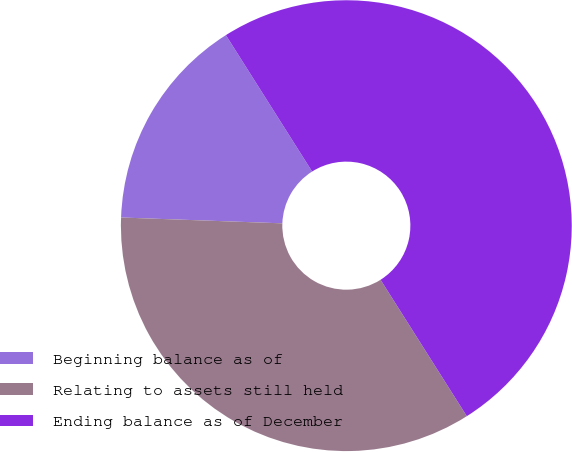Convert chart to OTSL. <chart><loc_0><loc_0><loc_500><loc_500><pie_chart><fcel>Beginning balance as of<fcel>Relating to assets still held<fcel>Ending balance as of December<nl><fcel>15.45%<fcel>34.55%<fcel>50.0%<nl></chart> 